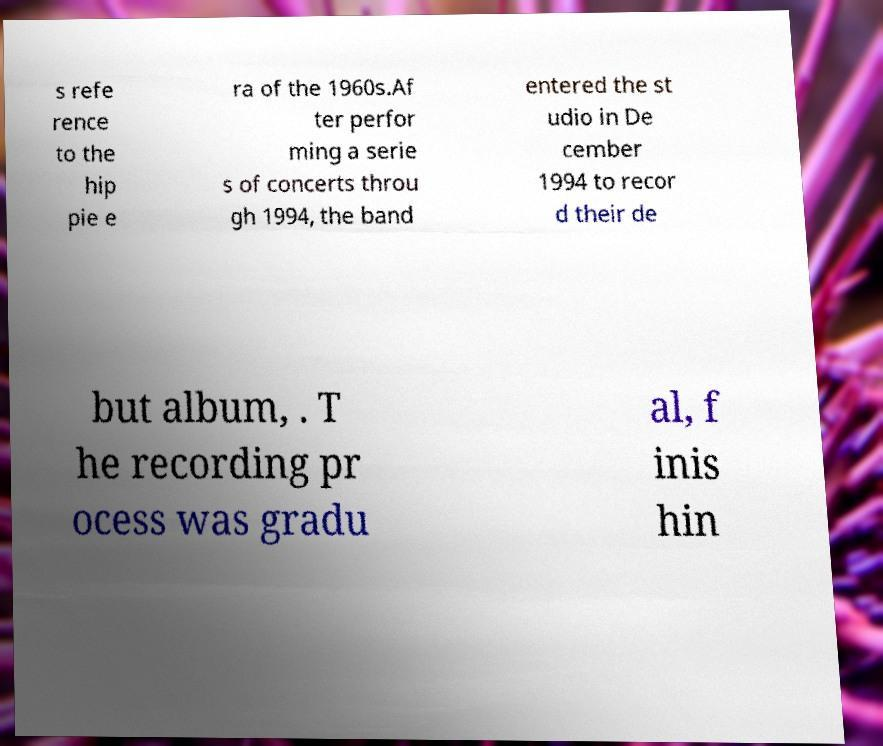Can you accurately transcribe the text from the provided image for me? s refe rence to the hip pie e ra of the 1960s.Af ter perfor ming a serie s of concerts throu gh 1994, the band entered the st udio in De cember 1994 to recor d their de but album, . T he recording pr ocess was gradu al, f inis hin 